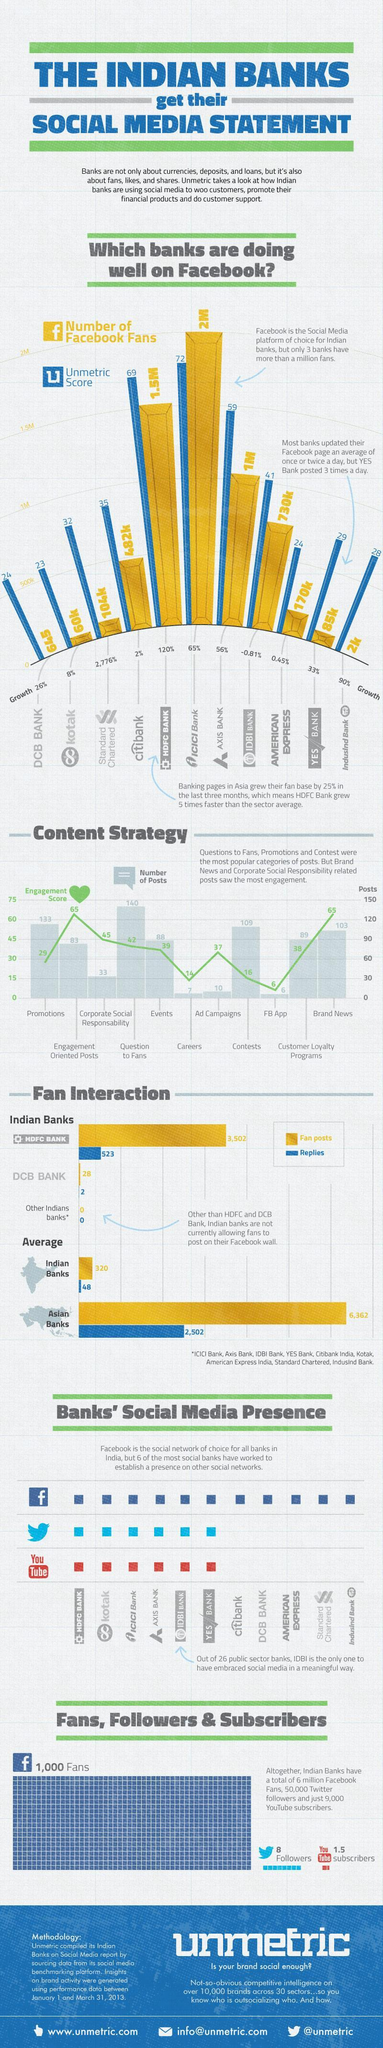How many contents have an engagement score greater than 50?
Answer the question with a short phrase. 2 How many contents have more than 100 posts? 4 Which all banks have more than 1 million fans on Facebook? HDFC bank, ICICI bank, Axis bank 